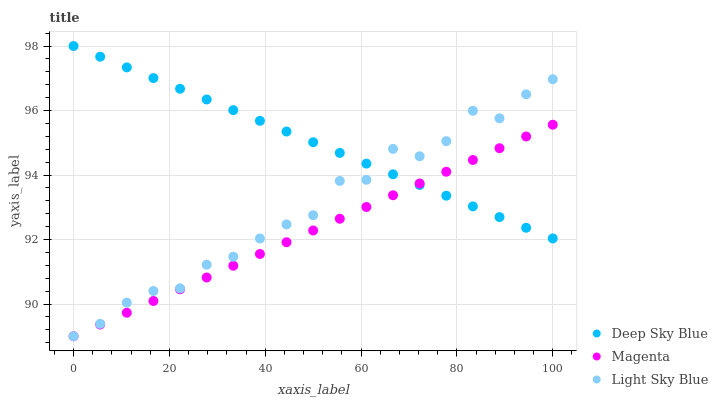Does Magenta have the minimum area under the curve?
Answer yes or no. Yes. Does Deep Sky Blue have the maximum area under the curve?
Answer yes or no. Yes. Does Light Sky Blue have the minimum area under the curve?
Answer yes or no. No. Does Light Sky Blue have the maximum area under the curve?
Answer yes or no. No. Is Magenta the smoothest?
Answer yes or no. Yes. Is Light Sky Blue the roughest?
Answer yes or no. Yes. Is Deep Sky Blue the smoothest?
Answer yes or no. No. Is Deep Sky Blue the roughest?
Answer yes or no. No. Does Magenta have the lowest value?
Answer yes or no. Yes. Does Deep Sky Blue have the lowest value?
Answer yes or no. No. Does Deep Sky Blue have the highest value?
Answer yes or no. Yes. Does Light Sky Blue have the highest value?
Answer yes or no. No. Does Deep Sky Blue intersect Light Sky Blue?
Answer yes or no. Yes. Is Deep Sky Blue less than Light Sky Blue?
Answer yes or no. No. Is Deep Sky Blue greater than Light Sky Blue?
Answer yes or no. No. 